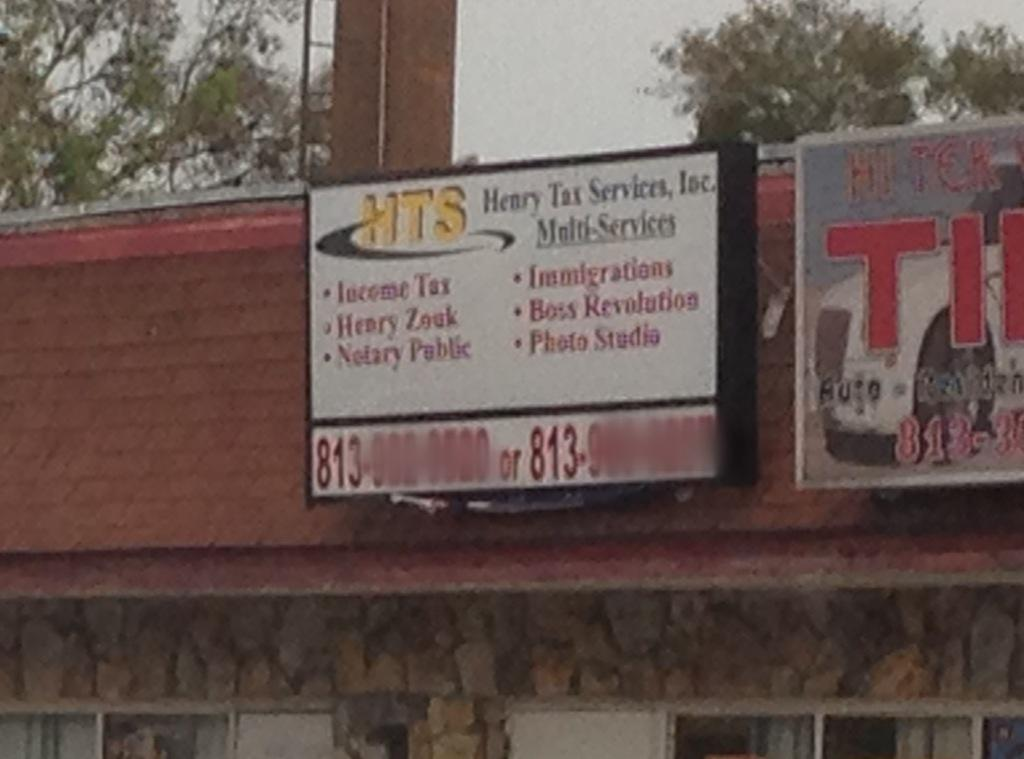<image>
Describe the image concisely. the numbers 813 that are on a sign 